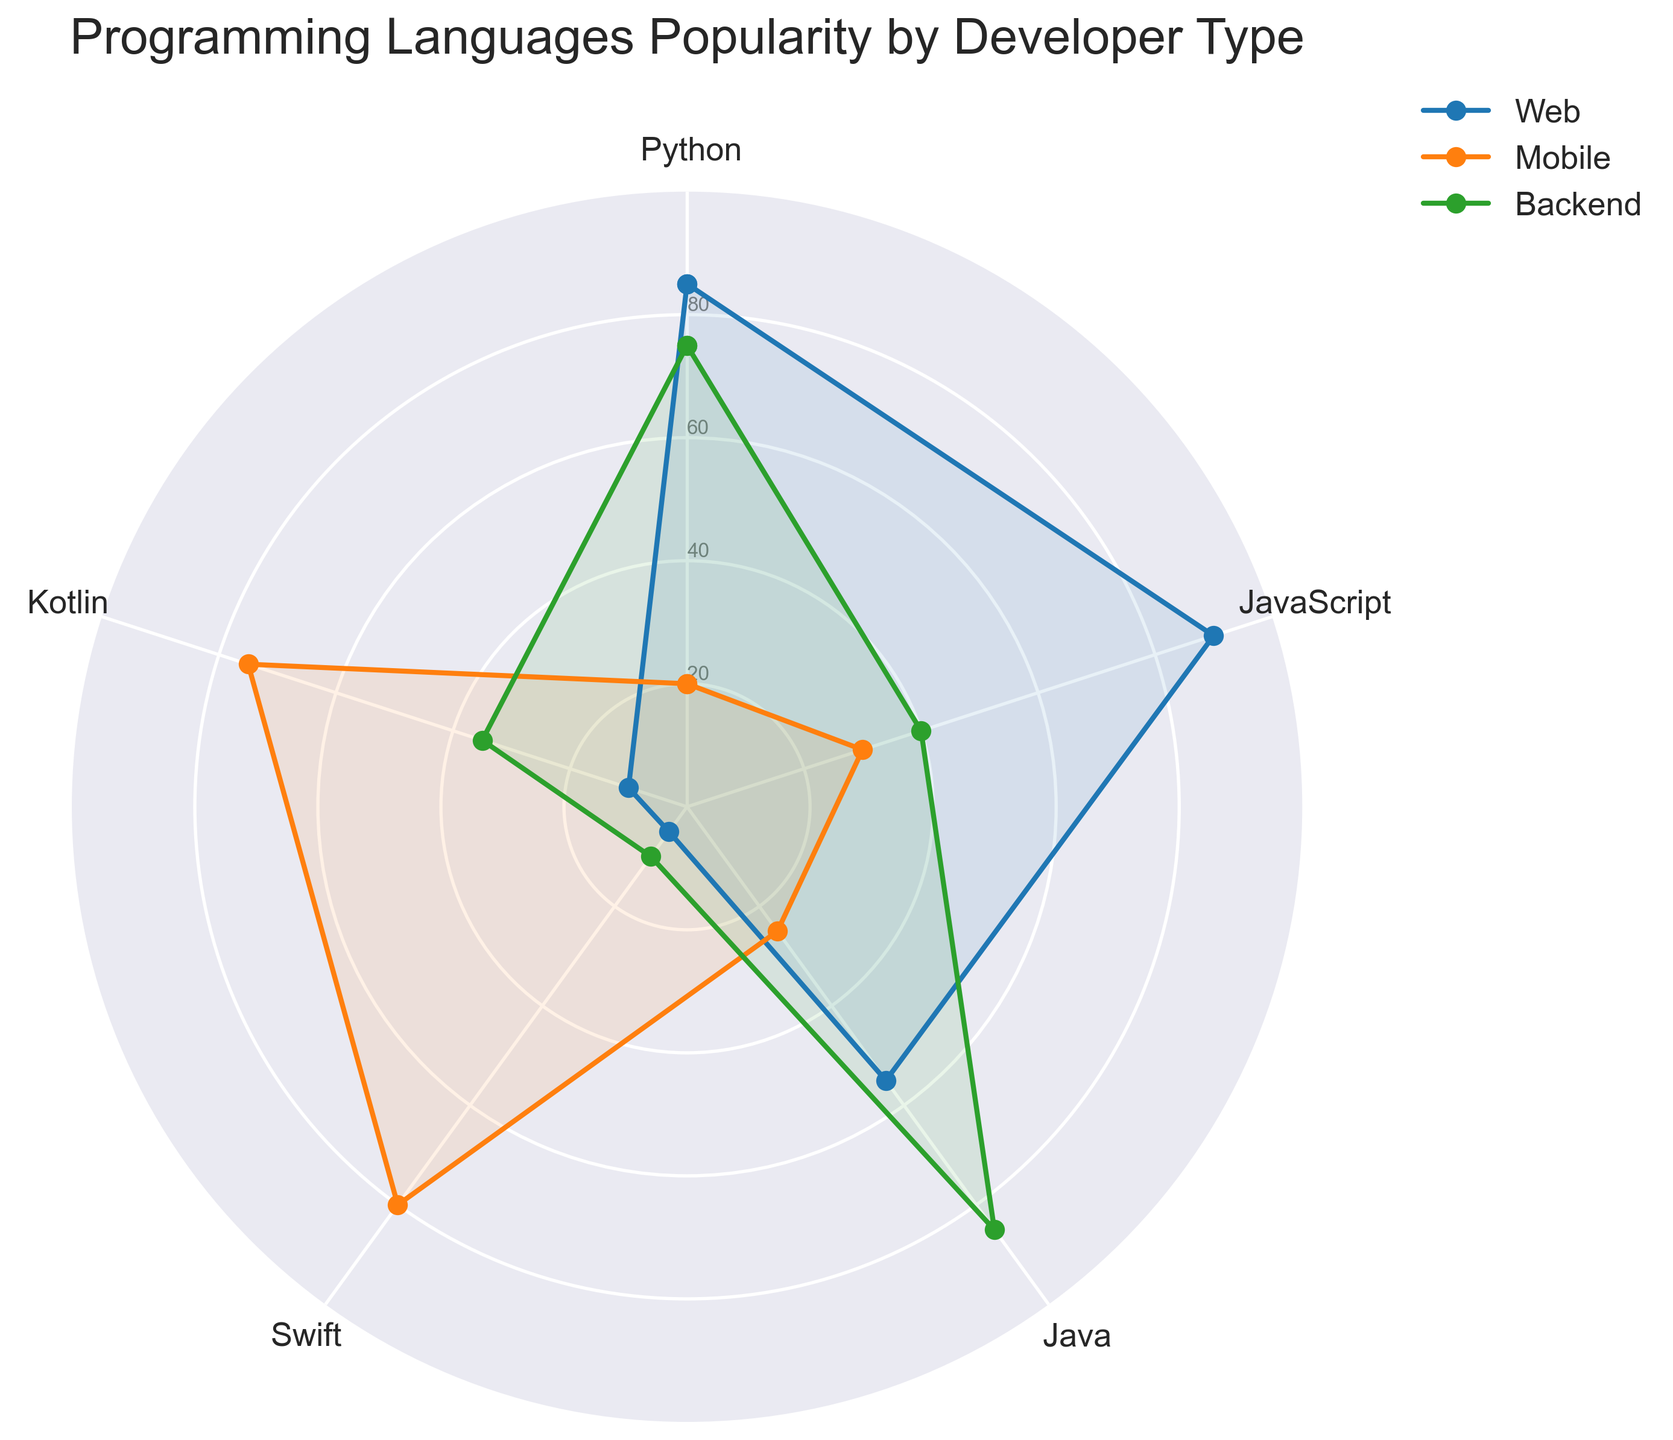What's the title of the figure? The title of the figure is usually displayed at the top and is clearly visible. In this case, the title is mentioned in the plotting code.
Answer: Programming Languages Popularity by Developer Type How many programming languages are represented in the chart? The chart displays programming languages as categories along the axes. By counting the categories, we can determine the number.
Answer: 5 Which developer type has the highest popularity for Java? Look at the values for Java along the Java axis and find the developer type with the maximum value. Backend has the highest value for Java.
Answer: Backend Compare Web and Mobile developers in terms of Kotlin popularity. Which group has a higher score? Check the Kotlin values for both Web and Mobile developers and compare them. Mobile developers have a higher score than Web developers.
Answer: Mobile What's the average popularity of Python across Web, Mobile, and Backend developers? Add the Python values of Web (85), Mobile (20), and Backend (75), and then divide by 3 to find the average.
Answer: (85 + 20 + 75) / 3 = 60 Which developer type has the least popularity for Swift? Look at the individual values for Swift for each developer type and find the minimum value. Both Web and Frontend developers have the lowest value, which is 5 for Swift.
Answer: Web and Frontend Does Frontend have a higher popularity for JavaScript than Mobile? Compare the JavaScript values for Frontend (95) and Mobile (30). Frontend has a higher value.
Answer: Yes What is the total popularity of Kotlin across Web and Backend developers? Add the Kotlin values for both Web (10) and Backend (35) developers to get the total.
Answer: 10 + 35 = 45 Which developer type has the highest overall popularity score when summing up all the programming languages? Sum the values for each programming language for all developer types and compare the totals to find the highest one. Web: 85+90+55+5+10=245, Mobile: 20+30+25+80+75=230, Backend: 75+40+85+10+35=245, Frontend: 60+95+25+5+20=205. Web and Backend have the highest total score.
Answer: Web and Backend 